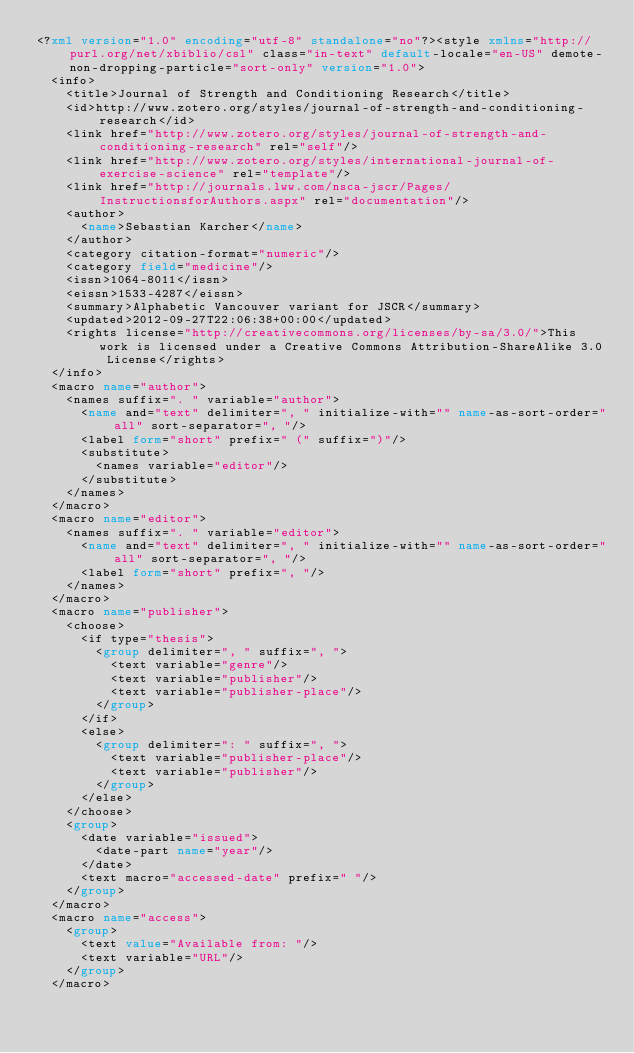Convert code to text. <code><loc_0><loc_0><loc_500><loc_500><_XML_><?xml version="1.0" encoding="utf-8" standalone="no"?><style xmlns="http://purl.org/net/xbiblio/csl" class="in-text" default-locale="en-US" demote-non-dropping-particle="sort-only" version="1.0">
  <info>
    <title>Journal of Strength and Conditioning Research</title>
    <id>http://www.zotero.org/styles/journal-of-strength-and-conditioning-research</id>
    <link href="http://www.zotero.org/styles/journal-of-strength-and-conditioning-research" rel="self"/>
    <link href="http://www.zotero.org/styles/international-journal-of-exercise-science" rel="template"/>
    <link href="http://journals.lww.com/nsca-jscr/Pages/InstructionsforAuthors.aspx" rel="documentation"/>
    <author>
      <name>Sebastian Karcher</name>
    </author>
    <category citation-format="numeric"/>
    <category field="medicine"/>
    <issn>1064-8011</issn>
    <eissn>1533-4287</eissn>
    <summary>Alphabetic Vancouver variant for JSCR</summary>
    <updated>2012-09-27T22:06:38+00:00</updated>
    <rights license="http://creativecommons.org/licenses/by-sa/3.0/">This work is licensed under a Creative Commons Attribution-ShareAlike 3.0 License</rights>
  </info>
  <macro name="author">
    <names suffix=". " variable="author">
      <name and="text" delimiter=", " initialize-with="" name-as-sort-order="all" sort-separator=", "/>
      <label form="short" prefix=" (" suffix=")"/>
      <substitute>
        <names variable="editor"/>
      </substitute>
    </names>
  </macro>
  <macro name="editor">
    <names suffix=". " variable="editor">
      <name and="text" delimiter=", " initialize-with="" name-as-sort-order="all" sort-separator=", "/>
      <label form="short" prefix=", "/>
    </names>
  </macro>
  <macro name="publisher">
    <choose>
      <if type="thesis">
        <group delimiter=", " suffix=", ">
          <text variable="genre"/>
          <text variable="publisher"/>
          <text variable="publisher-place"/>
        </group>
      </if>
      <else>
        <group delimiter=": " suffix=", ">
          <text variable="publisher-place"/>
          <text variable="publisher"/>
        </group>
      </else>
    </choose>
    <group>
      <date variable="issued">
        <date-part name="year"/>
      </date>
      <text macro="accessed-date" prefix=" "/>
    </group>
  </macro>
  <macro name="access">
    <group>
      <text value="Available from: "/>
      <text variable="URL"/>
    </group>
  </macro></code> 